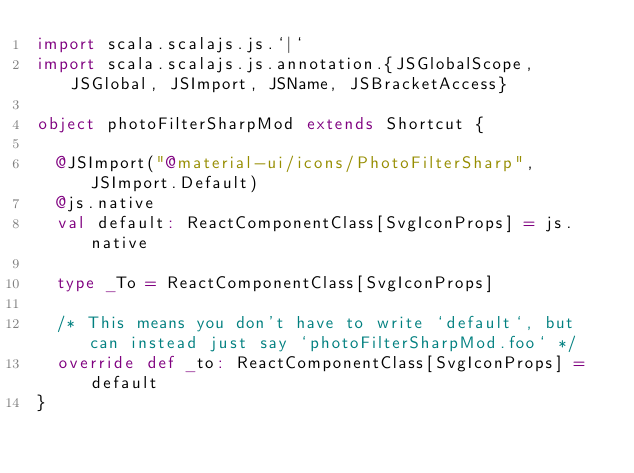<code> <loc_0><loc_0><loc_500><loc_500><_Scala_>import scala.scalajs.js.`|`
import scala.scalajs.js.annotation.{JSGlobalScope, JSGlobal, JSImport, JSName, JSBracketAccess}

object photoFilterSharpMod extends Shortcut {
  
  @JSImport("@material-ui/icons/PhotoFilterSharp", JSImport.Default)
  @js.native
  val default: ReactComponentClass[SvgIconProps] = js.native
  
  type _To = ReactComponentClass[SvgIconProps]
  
  /* This means you don't have to write `default`, but can instead just say `photoFilterSharpMod.foo` */
  override def _to: ReactComponentClass[SvgIconProps] = default
}
</code> 